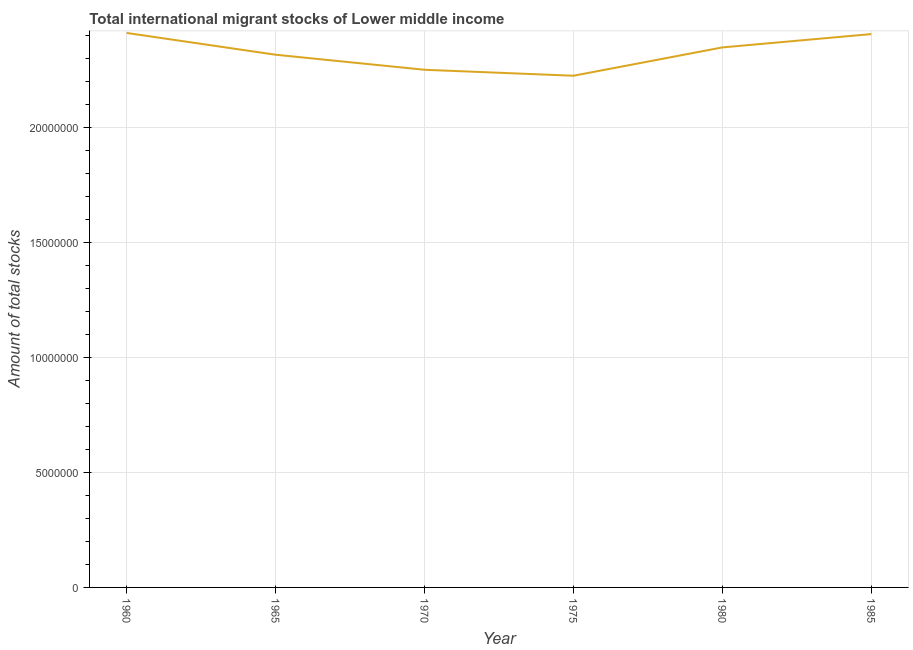What is the total number of international migrant stock in 1965?
Your answer should be compact. 2.31e+07. Across all years, what is the maximum total number of international migrant stock?
Provide a short and direct response. 2.41e+07. Across all years, what is the minimum total number of international migrant stock?
Your response must be concise. 2.22e+07. In which year was the total number of international migrant stock minimum?
Ensure brevity in your answer.  1975. What is the sum of the total number of international migrant stock?
Provide a short and direct response. 1.39e+08. What is the difference between the total number of international migrant stock in 1960 and 1975?
Make the answer very short. 1.86e+06. What is the average total number of international migrant stock per year?
Your answer should be very brief. 2.32e+07. What is the median total number of international migrant stock?
Offer a terse response. 2.33e+07. In how many years, is the total number of international migrant stock greater than 16000000 ?
Give a very brief answer. 6. Do a majority of the years between 1960 and 1965 (inclusive) have total number of international migrant stock greater than 7000000 ?
Make the answer very short. Yes. What is the ratio of the total number of international migrant stock in 1975 to that in 1980?
Your response must be concise. 0.95. Is the difference between the total number of international migrant stock in 1965 and 1985 greater than the difference between any two years?
Make the answer very short. No. What is the difference between the highest and the second highest total number of international migrant stock?
Give a very brief answer. 4.87e+04. What is the difference between the highest and the lowest total number of international migrant stock?
Your answer should be compact. 1.86e+06. In how many years, is the total number of international migrant stock greater than the average total number of international migrant stock taken over all years?
Make the answer very short. 3. How many lines are there?
Offer a very short reply. 1. What is the difference between two consecutive major ticks on the Y-axis?
Keep it short and to the point. 5.00e+06. Are the values on the major ticks of Y-axis written in scientific E-notation?
Ensure brevity in your answer.  No. Does the graph contain grids?
Your response must be concise. Yes. What is the title of the graph?
Ensure brevity in your answer.  Total international migrant stocks of Lower middle income. What is the label or title of the Y-axis?
Provide a succinct answer. Amount of total stocks. What is the Amount of total stocks of 1960?
Provide a succinct answer. 2.41e+07. What is the Amount of total stocks in 1965?
Your response must be concise. 2.31e+07. What is the Amount of total stocks of 1970?
Ensure brevity in your answer.  2.25e+07. What is the Amount of total stocks of 1975?
Ensure brevity in your answer.  2.22e+07. What is the Amount of total stocks of 1980?
Your answer should be very brief. 2.35e+07. What is the Amount of total stocks in 1985?
Ensure brevity in your answer.  2.40e+07. What is the difference between the Amount of total stocks in 1960 and 1965?
Offer a very short reply. 9.46e+05. What is the difference between the Amount of total stocks in 1960 and 1970?
Provide a succinct answer. 1.60e+06. What is the difference between the Amount of total stocks in 1960 and 1975?
Your answer should be very brief. 1.86e+06. What is the difference between the Amount of total stocks in 1960 and 1980?
Offer a very short reply. 6.28e+05. What is the difference between the Amount of total stocks in 1960 and 1985?
Offer a terse response. 4.87e+04. What is the difference between the Amount of total stocks in 1965 and 1970?
Keep it short and to the point. 6.54e+05. What is the difference between the Amount of total stocks in 1965 and 1975?
Provide a succinct answer. 9.13e+05. What is the difference between the Amount of total stocks in 1965 and 1980?
Offer a terse response. -3.18e+05. What is the difference between the Amount of total stocks in 1965 and 1985?
Make the answer very short. -8.97e+05. What is the difference between the Amount of total stocks in 1970 and 1975?
Ensure brevity in your answer.  2.59e+05. What is the difference between the Amount of total stocks in 1970 and 1980?
Give a very brief answer. -9.72e+05. What is the difference between the Amount of total stocks in 1970 and 1985?
Ensure brevity in your answer.  -1.55e+06. What is the difference between the Amount of total stocks in 1975 and 1980?
Ensure brevity in your answer.  -1.23e+06. What is the difference between the Amount of total stocks in 1975 and 1985?
Your response must be concise. -1.81e+06. What is the difference between the Amount of total stocks in 1980 and 1985?
Provide a succinct answer. -5.79e+05. What is the ratio of the Amount of total stocks in 1960 to that in 1965?
Your answer should be very brief. 1.04. What is the ratio of the Amount of total stocks in 1960 to that in 1970?
Your answer should be compact. 1.07. What is the ratio of the Amount of total stocks in 1960 to that in 1975?
Ensure brevity in your answer.  1.08. What is the ratio of the Amount of total stocks in 1960 to that in 1985?
Make the answer very short. 1. What is the ratio of the Amount of total stocks in 1965 to that in 1975?
Offer a terse response. 1.04. What is the ratio of the Amount of total stocks in 1965 to that in 1980?
Offer a very short reply. 0.99. What is the ratio of the Amount of total stocks in 1965 to that in 1985?
Your answer should be very brief. 0.96. What is the ratio of the Amount of total stocks in 1970 to that in 1975?
Provide a succinct answer. 1.01. What is the ratio of the Amount of total stocks in 1970 to that in 1985?
Keep it short and to the point. 0.94. What is the ratio of the Amount of total stocks in 1975 to that in 1980?
Ensure brevity in your answer.  0.95. What is the ratio of the Amount of total stocks in 1975 to that in 1985?
Offer a terse response. 0.93. 